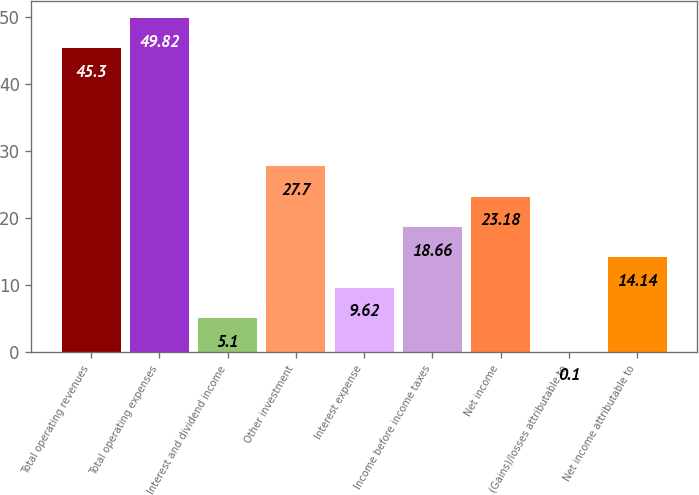<chart> <loc_0><loc_0><loc_500><loc_500><bar_chart><fcel>Total operating revenues<fcel>Total operating expenses<fcel>Interest and dividend income<fcel>Other investment<fcel>Interest expense<fcel>Income before income taxes<fcel>Net income<fcel>(Gains)/losses attributable to<fcel>Net income attributable to<nl><fcel>45.3<fcel>49.82<fcel>5.1<fcel>27.7<fcel>9.62<fcel>18.66<fcel>23.18<fcel>0.1<fcel>14.14<nl></chart> 